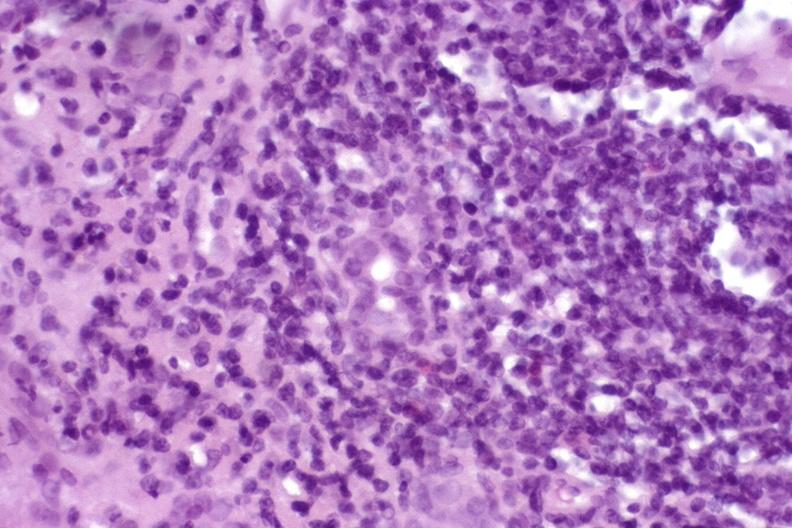what is present?
Answer the question using a single word or phrase. Liver 